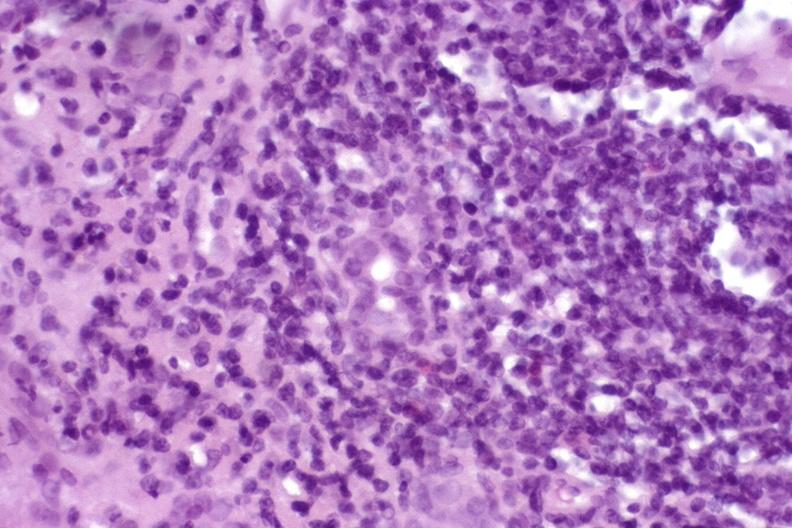what is present?
Answer the question using a single word or phrase. Liver 